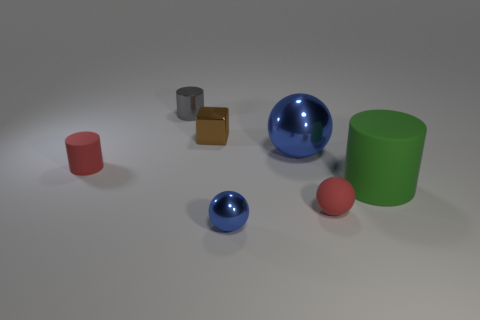Add 1 gray metal things. How many objects exist? 8 Subtract all cylinders. How many objects are left? 4 Add 3 rubber cylinders. How many rubber cylinders exist? 5 Subtract 1 red cylinders. How many objects are left? 6 Subtract all small shiny things. Subtract all brown objects. How many objects are left? 3 Add 2 small red rubber objects. How many small red rubber objects are left? 4 